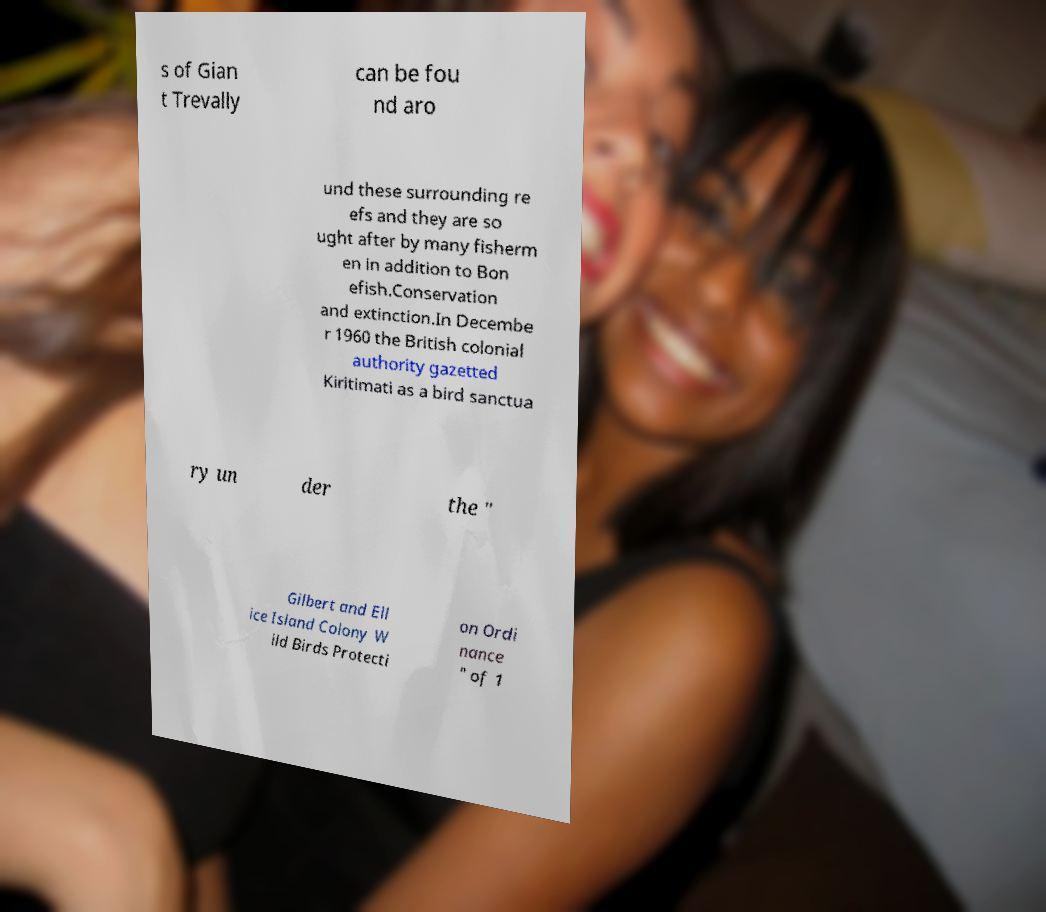I need the written content from this picture converted into text. Can you do that? s of Gian t Trevally can be fou nd aro und these surrounding re efs and they are so ught after by many fisherm en in addition to Bon efish.Conservation and extinction.In Decembe r 1960 the British colonial authority gazetted Kiritimati as a bird sanctua ry un der the " Gilbert and Ell ice Island Colony W ild Birds Protecti on Ordi nance " of 1 